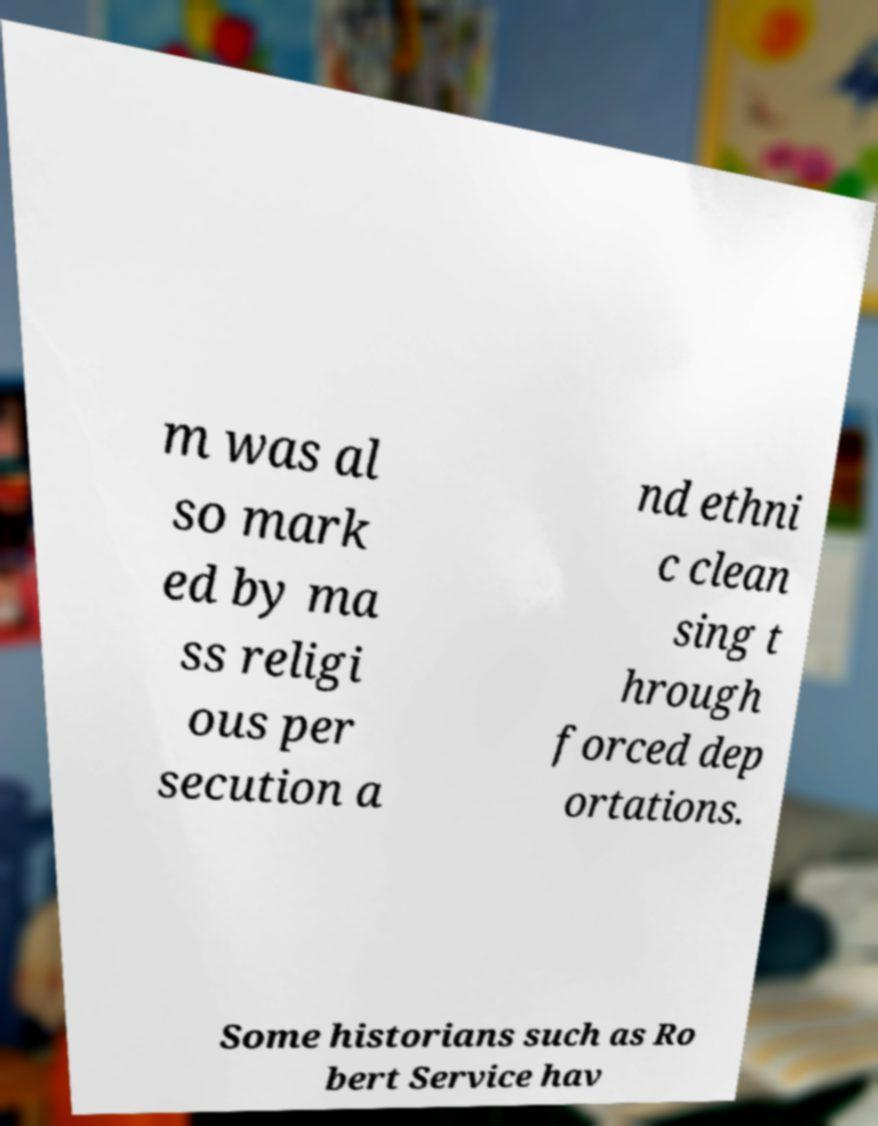Could you assist in decoding the text presented in this image and type it out clearly? m was al so mark ed by ma ss religi ous per secution a nd ethni c clean sing t hrough forced dep ortations. Some historians such as Ro bert Service hav 